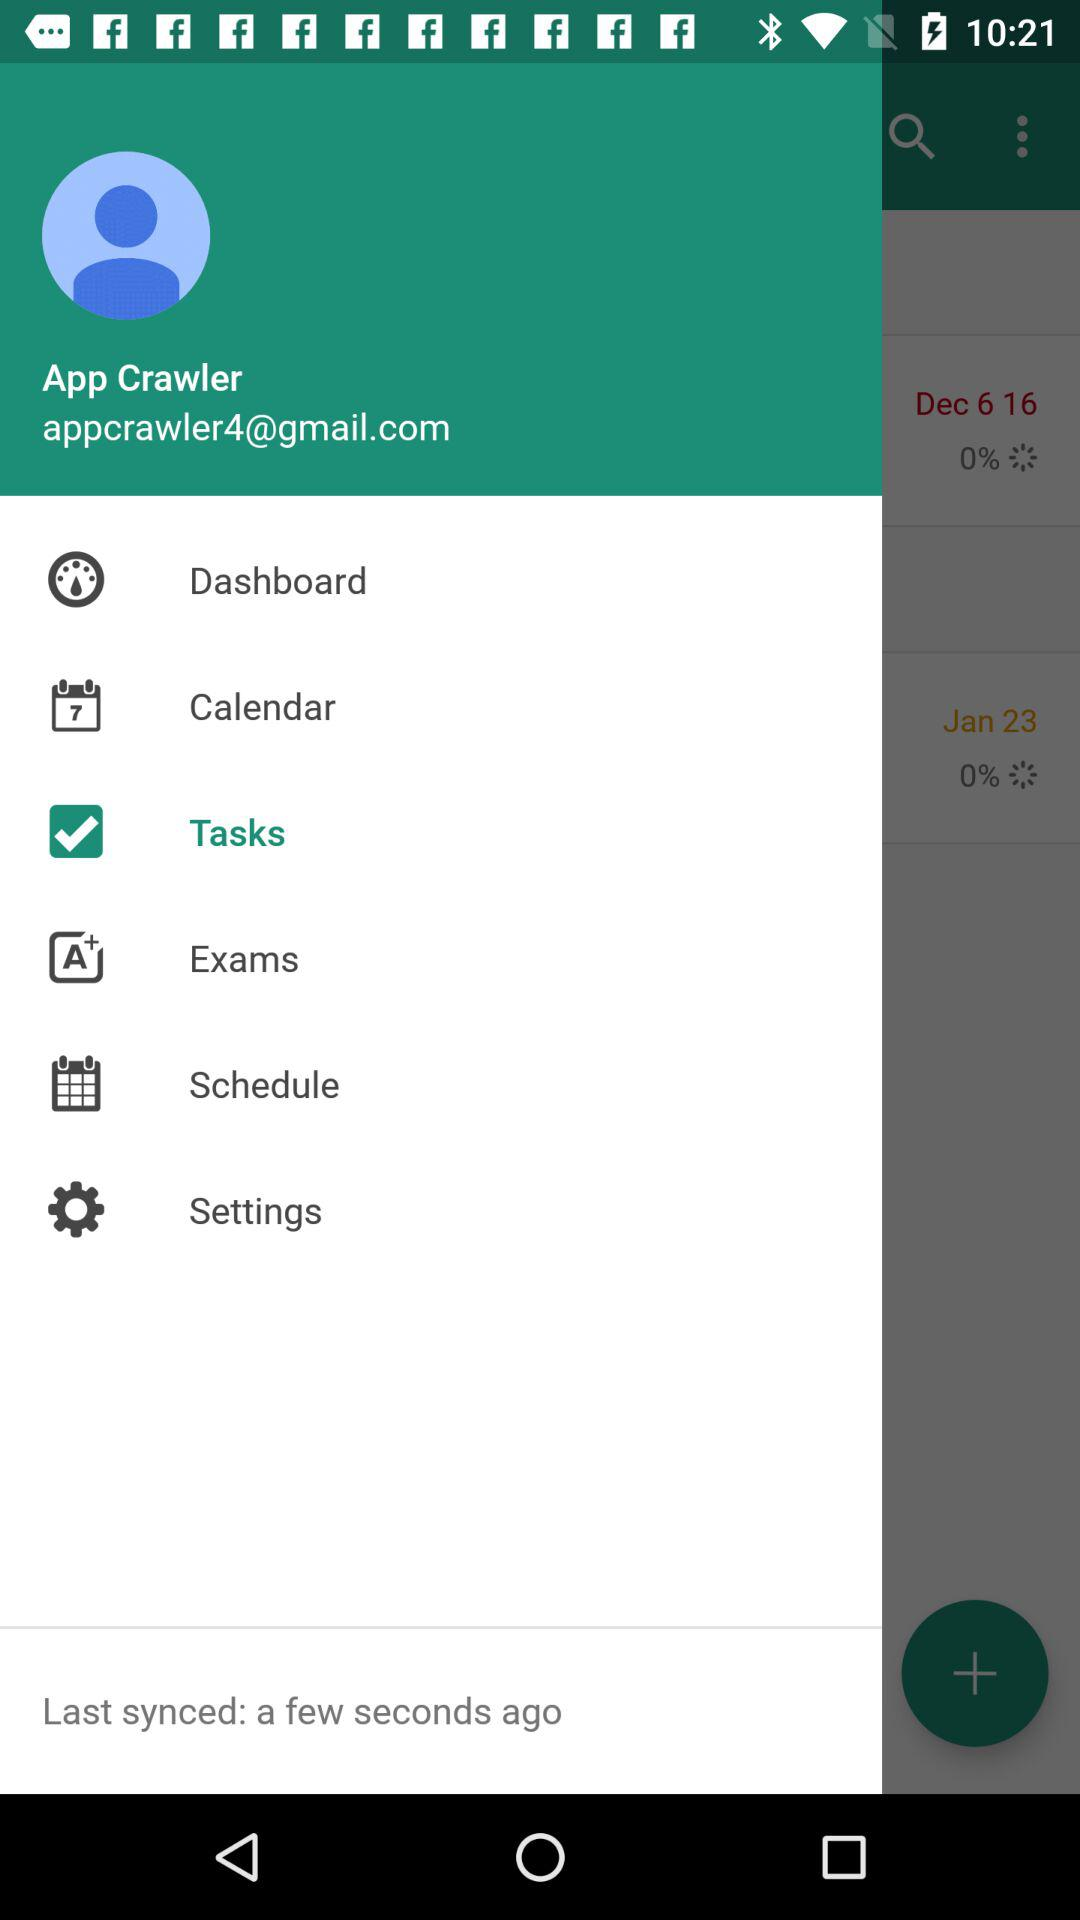How many items have a percent sign in their text?
Answer the question using a single word or phrase. 2 